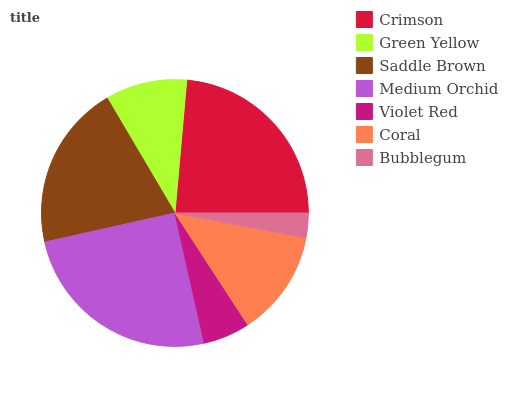Is Bubblegum the minimum?
Answer yes or no. Yes. Is Medium Orchid the maximum?
Answer yes or no. Yes. Is Green Yellow the minimum?
Answer yes or no. No. Is Green Yellow the maximum?
Answer yes or no. No. Is Crimson greater than Green Yellow?
Answer yes or no. Yes. Is Green Yellow less than Crimson?
Answer yes or no. Yes. Is Green Yellow greater than Crimson?
Answer yes or no. No. Is Crimson less than Green Yellow?
Answer yes or no. No. Is Coral the high median?
Answer yes or no. Yes. Is Coral the low median?
Answer yes or no. Yes. Is Crimson the high median?
Answer yes or no. No. Is Violet Red the low median?
Answer yes or no. No. 